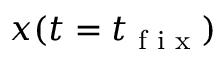Convert formula to latex. <formula><loc_0><loc_0><loc_500><loc_500>x ( t = t _ { f i x } )</formula> 